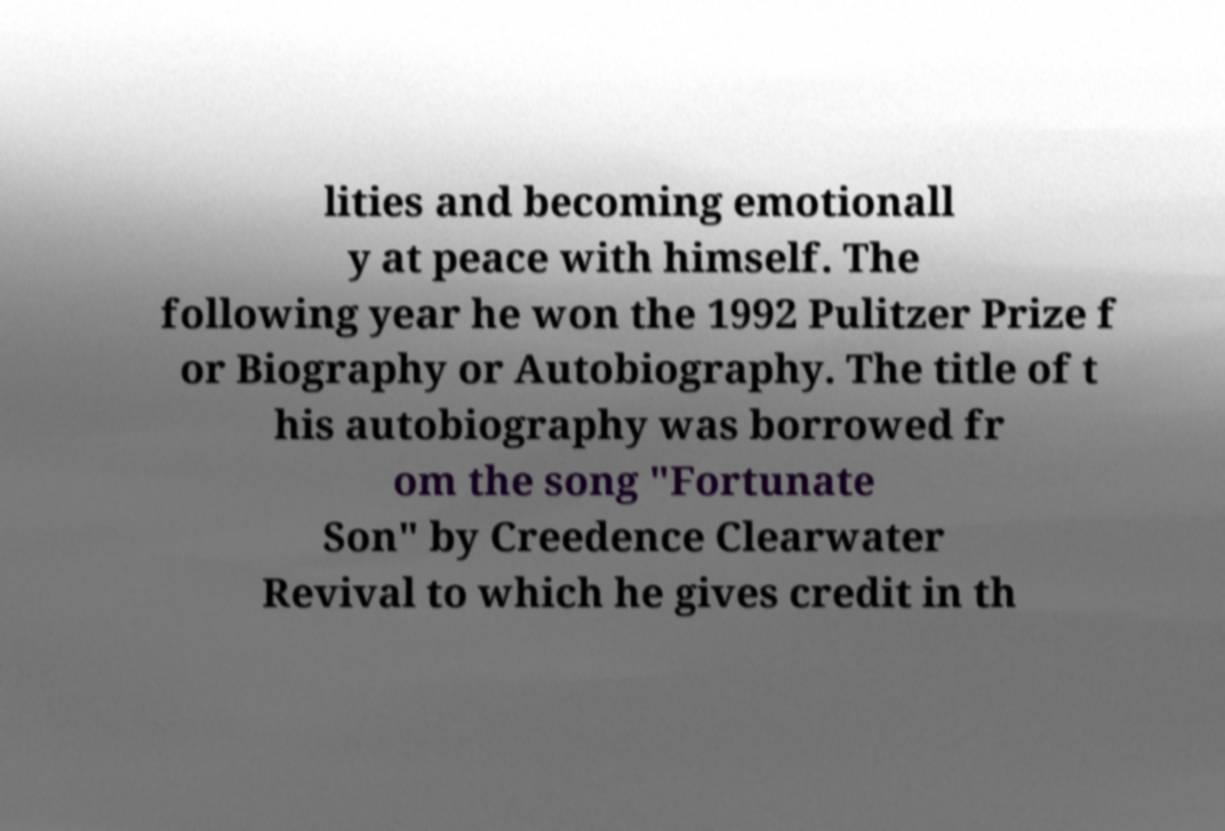I need the written content from this picture converted into text. Can you do that? lities and becoming emotionall y at peace with himself. The following year he won the 1992 Pulitzer Prize f or Biography or Autobiography. The title of t his autobiography was borrowed fr om the song "Fortunate Son" by Creedence Clearwater Revival to which he gives credit in th 